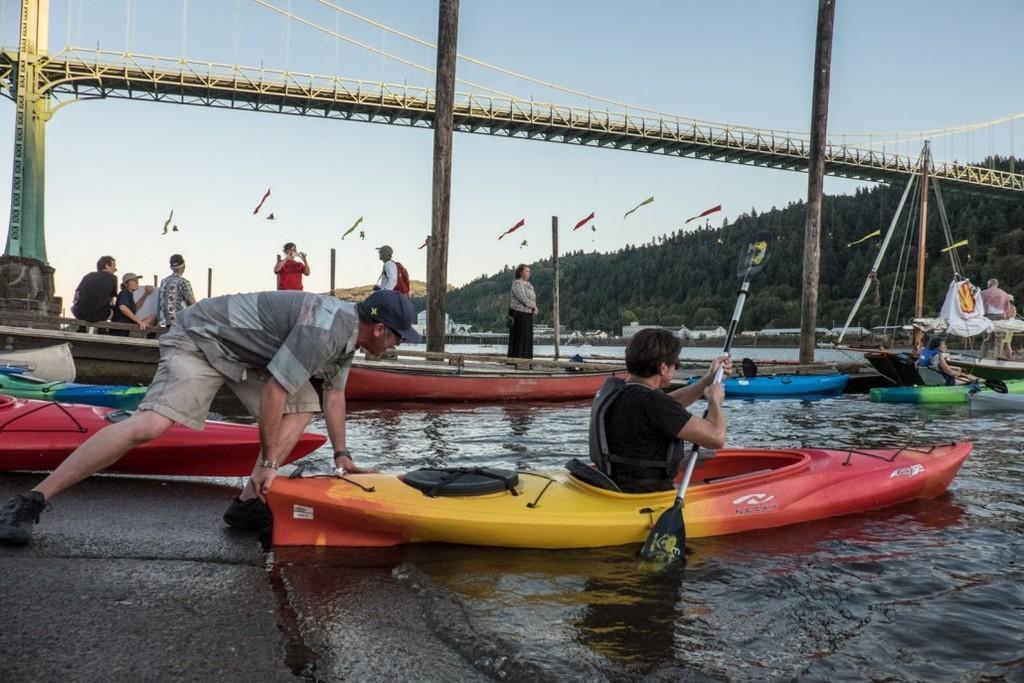In one or two sentences, can you explain what this image depicts? In this image, we can see persons wearing clothes. There are some boats floating on the water. There is a hill on the right side of the image. There are poles in the middle of the image. There is a bridge and sky at the top of the image. 